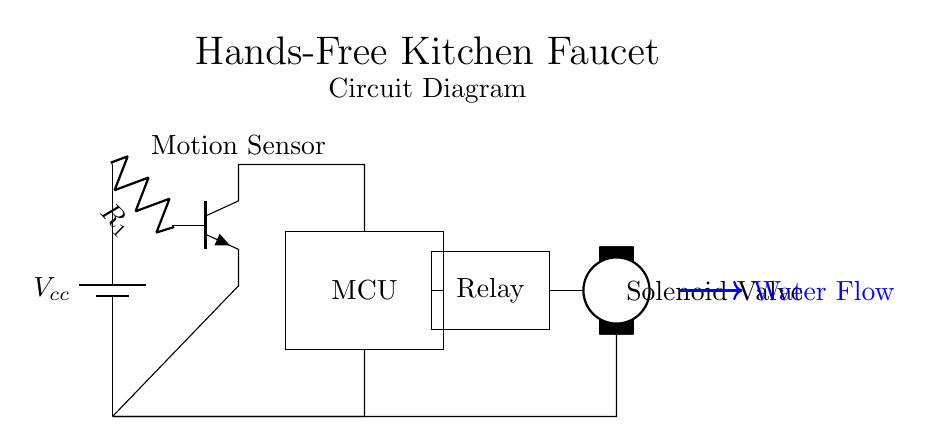What is the main purpose of this circuit? The main purpose of the circuit is to automate a kitchen faucet using a motion sensor, allowing hands-free operation when motion is detected.
Answer: automate kitchen faucet What component detects motion? The motion sensor is the component responsible for detecting motion in the circuit.
Answer: motion sensor What does the relay control? The relay controls the operation of the solenoid valve, which allows or blocks water flow based on commands from the microcontroller.
Answer: solenoid valve How many main components are in this circuit? The circuit consists of four main components: a motion sensor, microcontroller, relay, and solenoid valve.
Answer: four What is the relationship between the microcontroller and the relay? The microcontroller sends signals to the relay to control its operation, which in turn controls the solenoid valve.
Answer: control What would happen if the motion sensor is not triggered? If the motion sensor is not triggered, the microcontroller will not send a signal to the relay, and the solenoid valve will remain closed, preventing water flow.
Answer: no water flow What type of circuit is this? This is a hands-free activation circuit designed specifically for a kitchen faucet, using motion detection technology.
Answer: hands-free activation circuit 